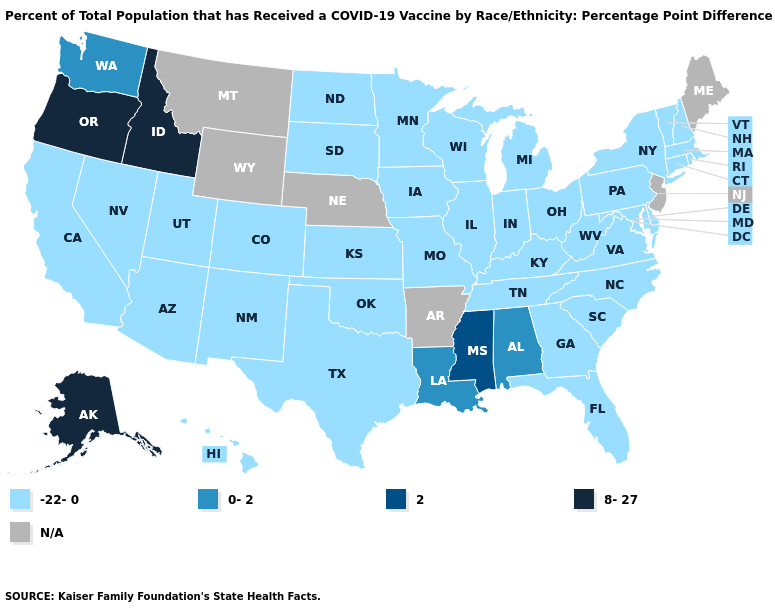What is the value of Rhode Island?
Give a very brief answer. -22-0. Among the states that border Wisconsin , which have the highest value?
Write a very short answer. Illinois, Iowa, Michigan, Minnesota. Among the states that border Vermont , which have the highest value?
Answer briefly. Massachusetts, New Hampshire, New York. What is the value of Alaska?
Write a very short answer. 8-27. What is the value of Virginia?
Write a very short answer. -22-0. Name the states that have a value in the range 2?
Quick response, please. Mississippi. Does Alaska have the lowest value in the West?
Give a very brief answer. No. Does the map have missing data?
Answer briefly. Yes. Name the states that have a value in the range 2?
Short answer required. Mississippi. Name the states that have a value in the range -22-0?
Be succinct. Arizona, California, Colorado, Connecticut, Delaware, Florida, Georgia, Hawaii, Illinois, Indiana, Iowa, Kansas, Kentucky, Maryland, Massachusetts, Michigan, Minnesota, Missouri, Nevada, New Hampshire, New Mexico, New York, North Carolina, North Dakota, Ohio, Oklahoma, Pennsylvania, Rhode Island, South Carolina, South Dakota, Tennessee, Texas, Utah, Vermont, Virginia, West Virginia, Wisconsin. What is the value of Illinois?
Give a very brief answer. -22-0. What is the value of Virginia?
Quick response, please. -22-0. Name the states that have a value in the range N/A?
Quick response, please. Arkansas, Maine, Montana, Nebraska, New Jersey, Wyoming. 